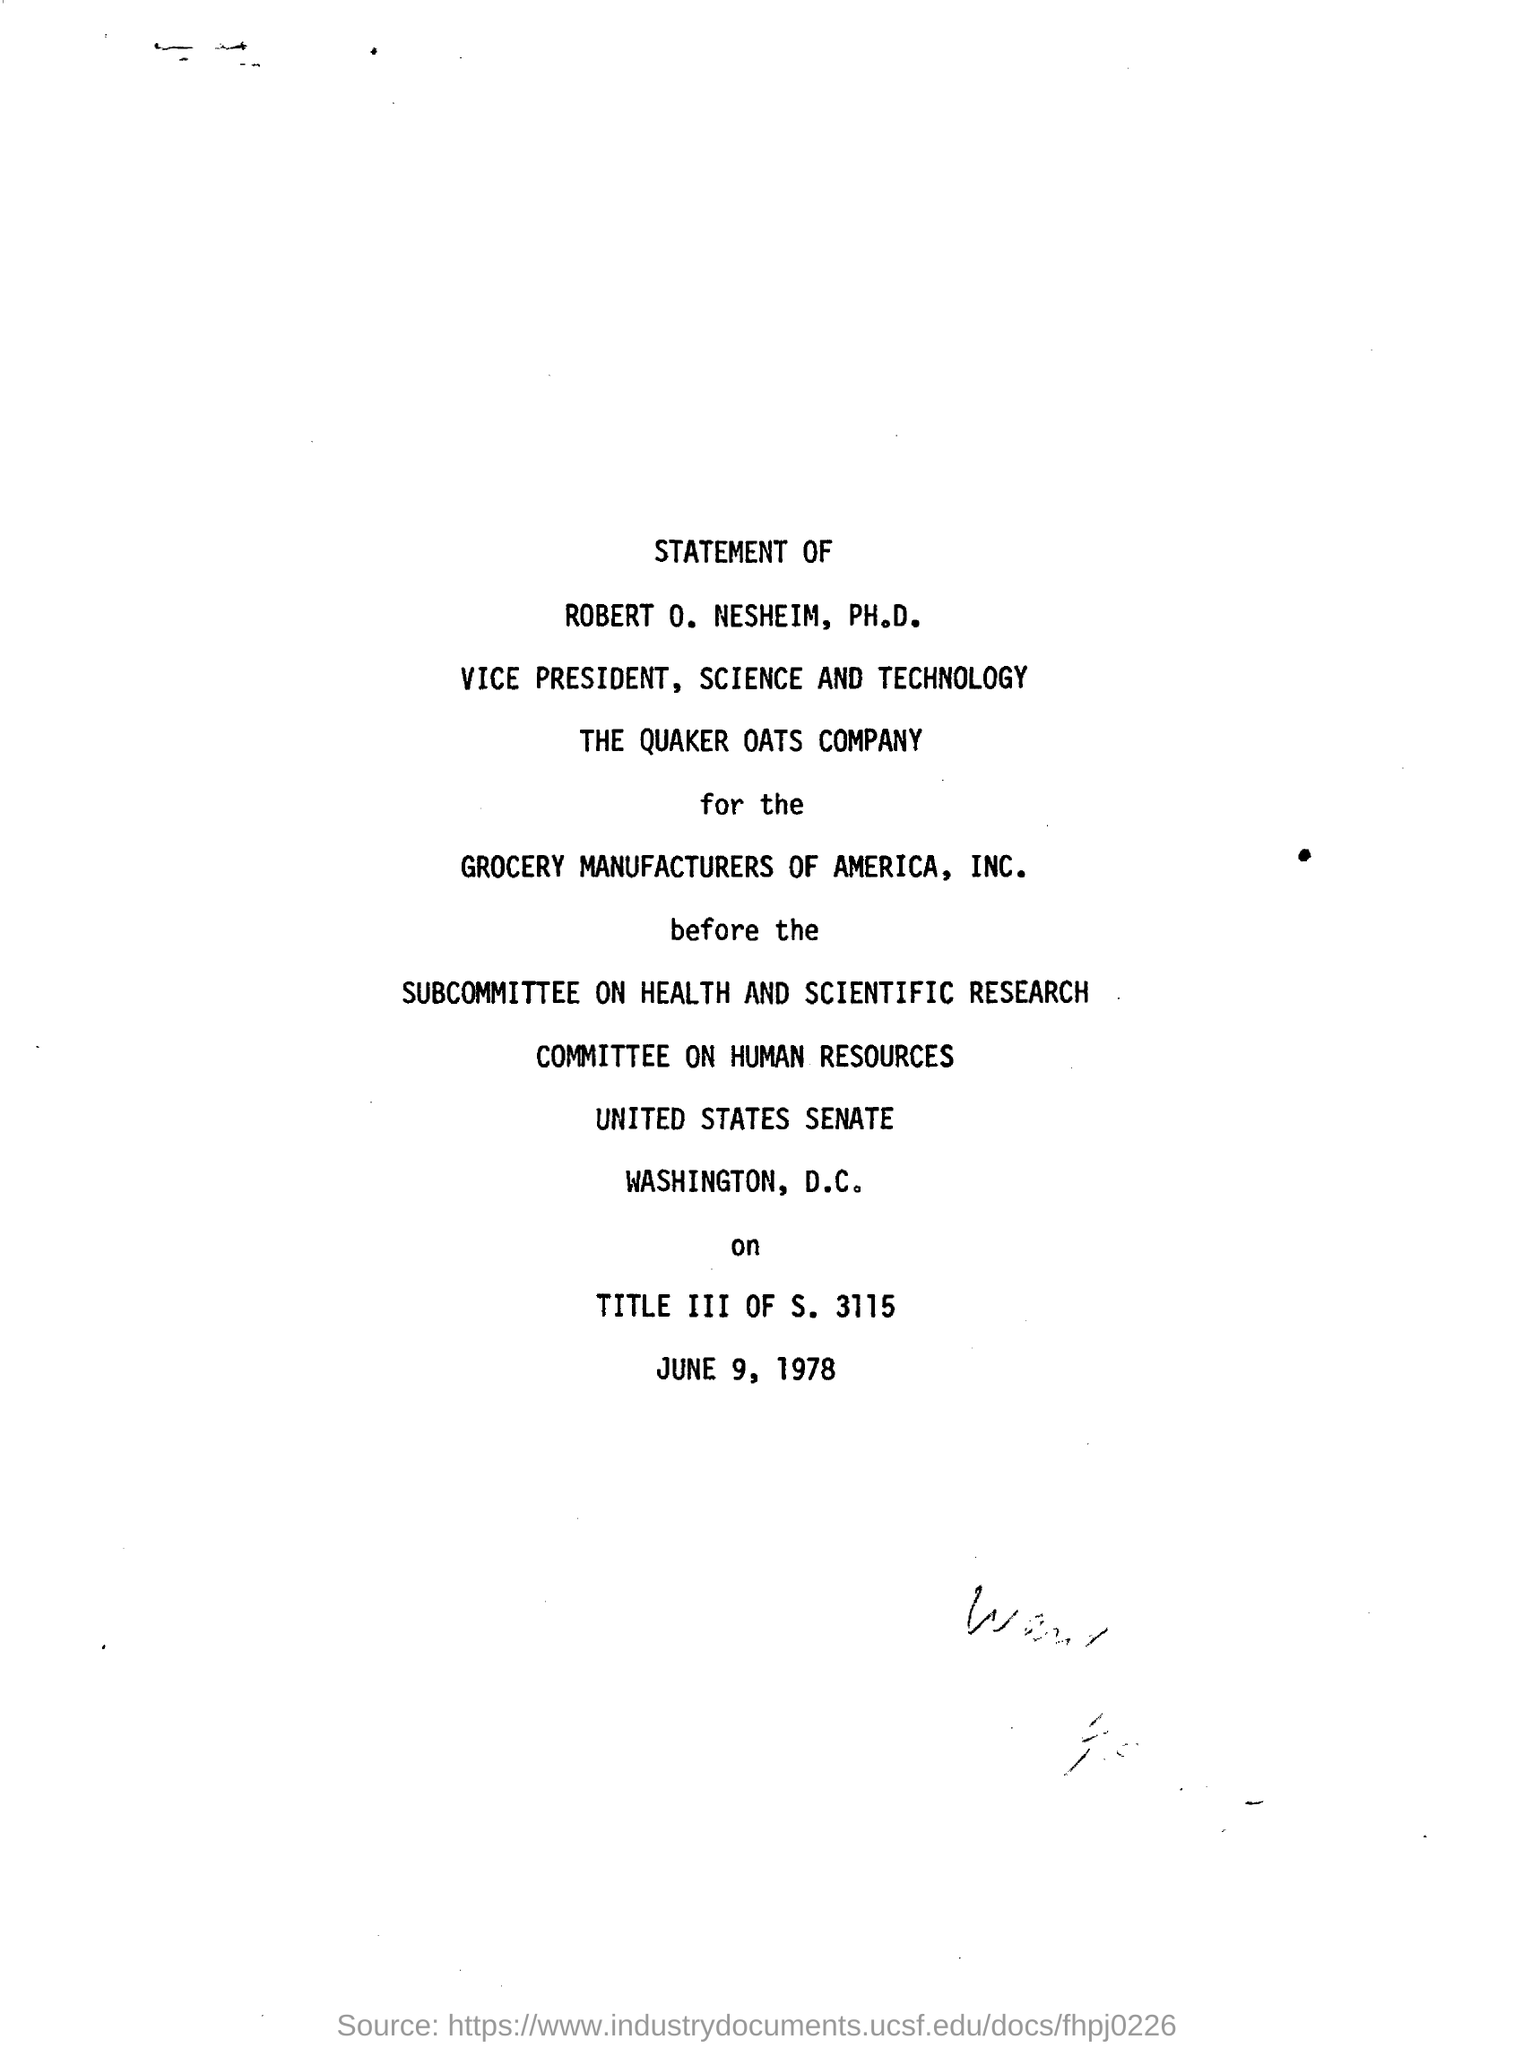On which date this statement was passed?
Your response must be concise. June 9, 1978. Who is the vice president of the quaker oats company?
Offer a very short reply. Robert o. nesheim. What was the subcommitteeon?
Your answer should be compact. HEALTH AND SCIENTIFIC RESEARCH. What is the date mentioned in the document?
Provide a succinct answer. JUNE 9, 1978. 